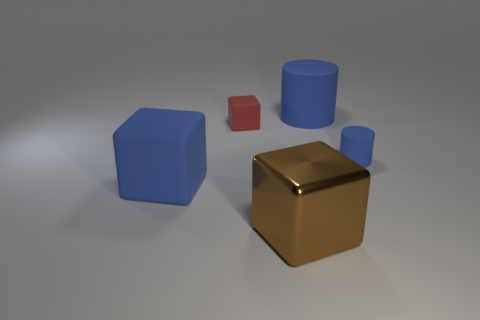Is there any other thing that has the same material as the big brown thing?
Your answer should be very brief. No. There is a blue matte thing that is to the left of the brown metallic cube; is there a brown metal thing that is to the left of it?
Offer a terse response. No. What is the material of the other large blue thing that is the same shape as the metallic thing?
Your answer should be compact. Rubber. There is a blue rubber thing behind the red thing; what number of small rubber blocks are behind it?
Provide a short and direct response. 0. Is there anything else that is the same color as the metal object?
Your response must be concise. No. What number of objects are brown shiny things or big blue rubber objects on the right side of the big blue matte block?
Make the answer very short. 2. There is a cylinder that is to the right of the large blue matte object that is to the right of the big blue rubber thing that is in front of the small cylinder; what is it made of?
Provide a succinct answer. Rubber. There is a red block that is made of the same material as the big blue block; what size is it?
Your answer should be compact. Small. The cylinder that is right of the blue matte cylinder to the left of the tiny matte cylinder is what color?
Provide a succinct answer. Blue. What number of brown cubes have the same material as the brown thing?
Your response must be concise. 0. 